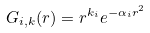<formula> <loc_0><loc_0><loc_500><loc_500>G _ { i , k } ( r ) = r ^ { k _ { i } } e ^ { - \alpha _ { i } r ^ { 2 } }</formula> 